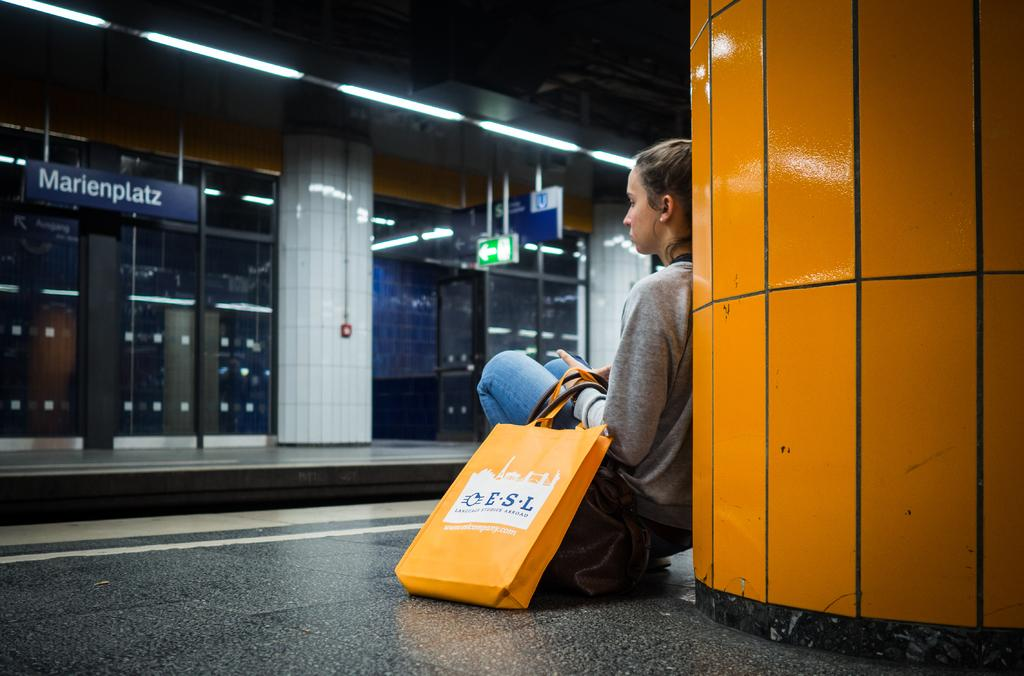Who is present in the image? There is a woman in the image. What is the woman doing with her bag? The woman has a bag on the ground. What architectural features can be seen in the image? There are pillars in the image. What type of signage is present in the image? Name boards are present in the image. What lighting is visible in the image? Lights are visible in the image. What type of doors are in the image? Glass doors are in the image. Are there any other objects in the image besides the woman and her bag? Yes, there are other objects in the image. What type of jewel is the woman wearing on her head in the image? There is no jewel visible on the woman's head in the image. Is the woman's friend present in the image? The provided facts do not mention the presence of a friend, so we cannot determine if the woman's friend is present in the image. 